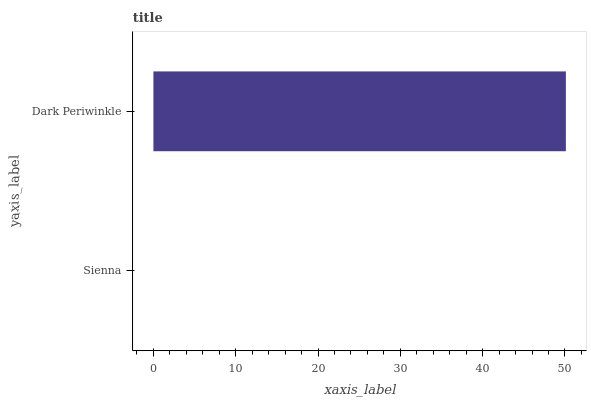Is Sienna the minimum?
Answer yes or no. Yes. Is Dark Periwinkle the maximum?
Answer yes or no. Yes. Is Dark Periwinkle the minimum?
Answer yes or no. No. Is Dark Periwinkle greater than Sienna?
Answer yes or no. Yes. Is Sienna less than Dark Periwinkle?
Answer yes or no. Yes. Is Sienna greater than Dark Periwinkle?
Answer yes or no. No. Is Dark Periwinkle less than Sienna?
Answer yes or no. No. Is Dark Periwinkle the high median?
Answer yes or no. Yes. Is Sienna the low median?
Answer yes or no. Yes. Is Sienna the high median?
Answer yes or no. No. Is Dark Periwinkle the low median?
Answer yes or no. No. 